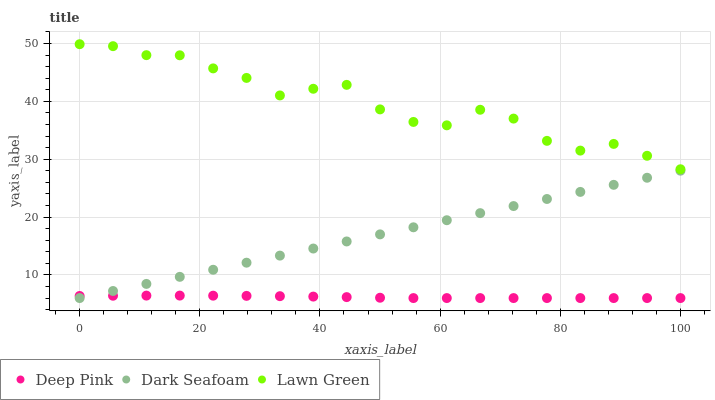Does Deep Pink have the minimum area under the curve?
Answer yes or no. Yes. Does Lawn Green have the maximum area under the curve?
Answer yes or no. Yes. Does Dark Seafoam have the minimum area under the curve?
Answer yes or no. No. Does Dark Seafoam have the maximum area under the curve?
Answer yes or no. No. Is Dark Seafoam the smoothest?
Answer yes or no. Yes. Is Lawn Green the roughest?
Answer yes or no. Yes. Is Deep Pink the smoothest?
Answer yes or no. No. Is Deep Pink the roughest?
Answer yes or no. No. Does Dark Seafoam have the lowest value?
Answer yes or no. Yes. Does Lawn Green have the highest value?
Answer yes or no. Yes. Does Dark Seafoam have the highest value?
Answer yes or no. No. Is Deep Pink less than Lawn Green?
Answer yes or no. Yes. Is Lawn Green greater than Deep Pink?
Answer yes or no. Yes. Does Dark Seafoam intersect Deep Pink?
Answer yes or no. Yes. Is Dark Seafoam less than Deep Pink?
Answer yes or no. No. Is Dark Seafoam greater than Deep Pink?
Answer yes or no. No. Does Deep Pink intersect Lawn Green?
Answer yes or no. No. 